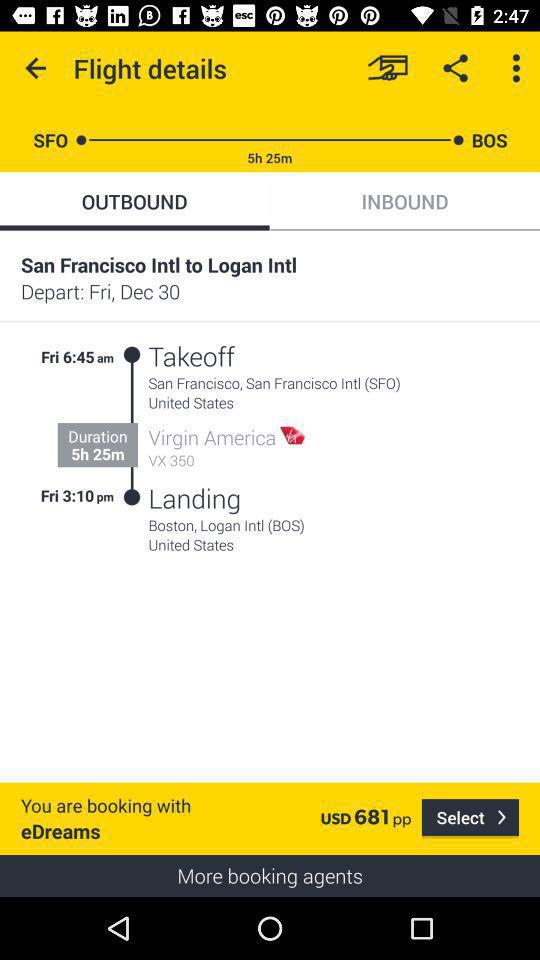What is the total travel time of this flight?
Answer the question using a single word or phrase. 5h 25m 